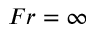Convert formula to latex. <formula><loc_0><loc_0><loc_500><loc_500>F r = \infty</formula> 